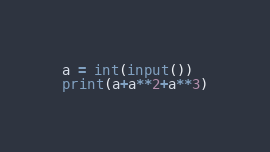<code> <loc_0><loc_0><loc_500><loc_500><_Python_>a = int(input())
print(a+a**2+a**3)
</code> 